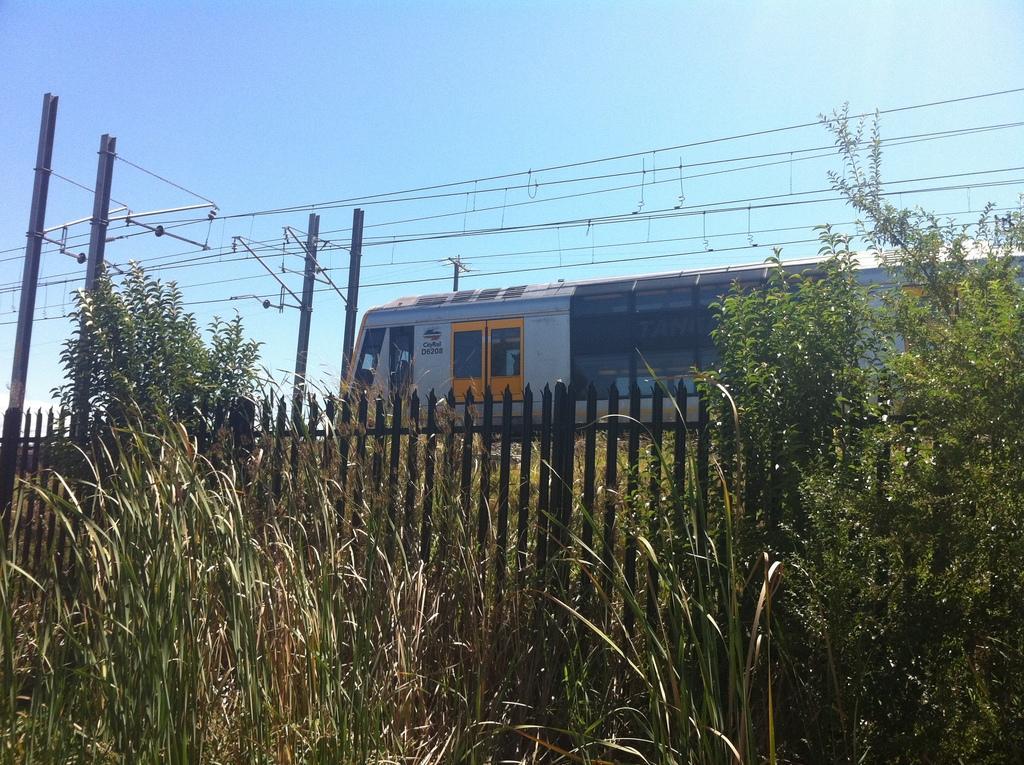Can you describe this image briefly? In this image in the front there are plants. In the center there is a fence and in the background there is a train running on the railway track and there are poles and on the poles there are wires attached to it. 